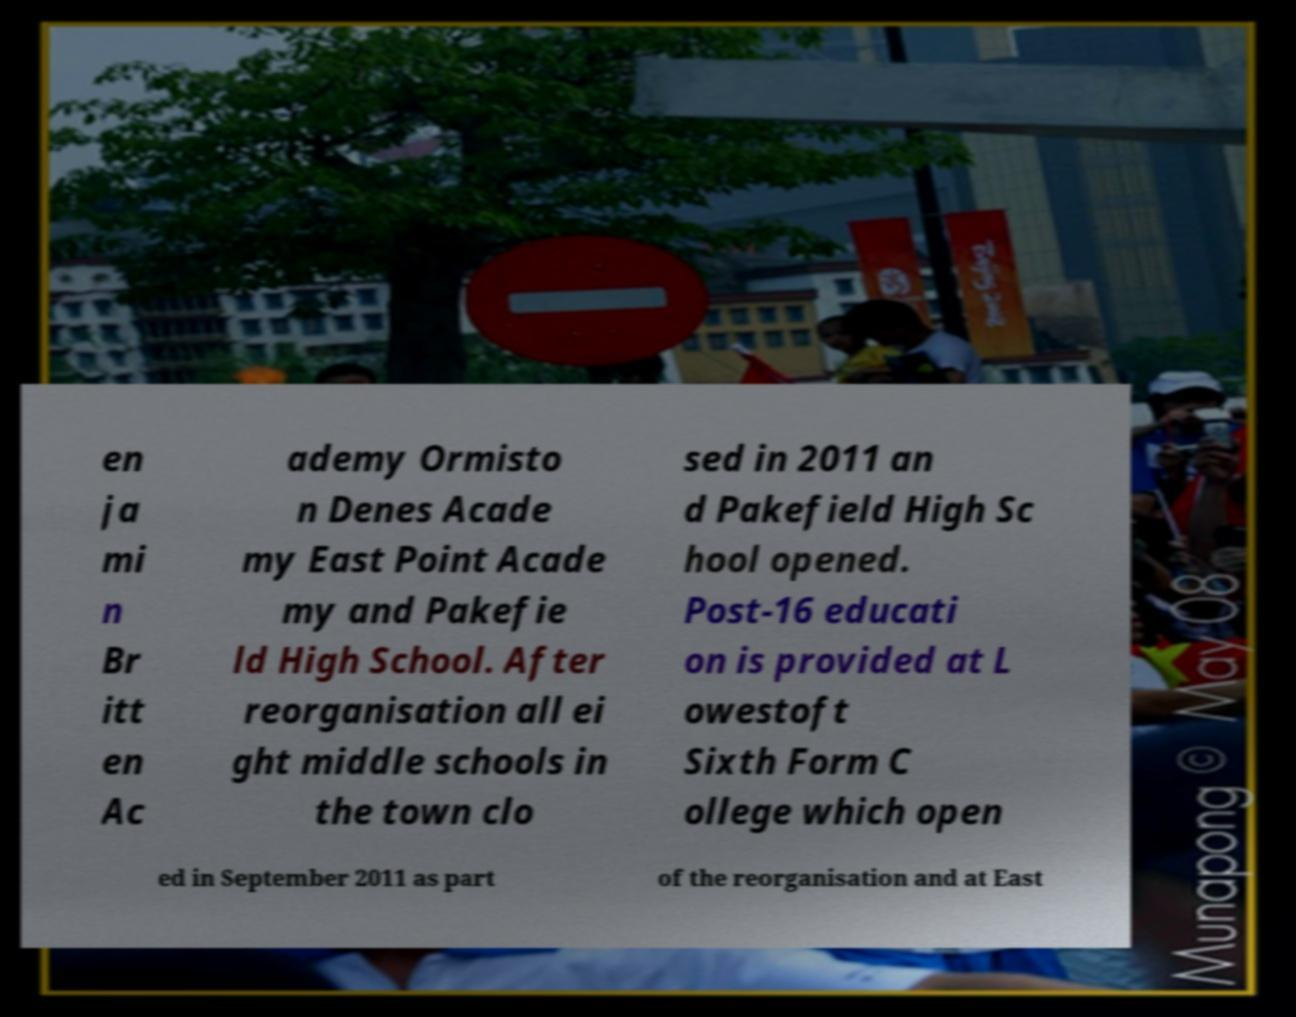For documentation purposes, I need the text within this image transcribed. Could you provide that? en ja mi n Br itt en Ac ademy Ormisto n Denes Acade my East Point Acade my and Pakefie ld High School. After reorganisation all ei ght middle schools in the town clo sed in 2011 an d Pakefield High Sc hool opened. Post-16 educati on is provided at L owestoft Sixth Form C ollege which open ed in September 2011 as part of the reorganisation and at East 